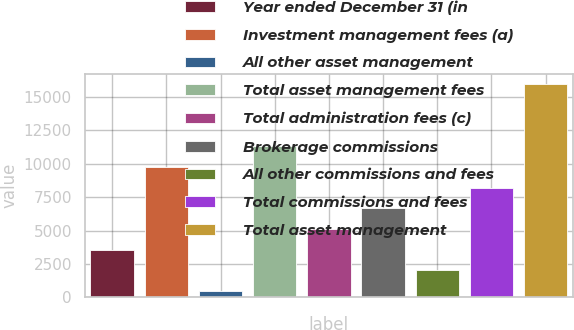Convert chart to OTSL. <chart><loc_0><loc_0><loc_500><loc_500><bar_chart><fcel>Year ended December 31 (in<fcel>Investment management fees (a)<fcel>All other asset management<fcel>Total asset management fees<fcel>Total administration fees (c)<fcel>Brokerage commissions<fcel>All other commissions and fees<fcel>Total commissions and fees<fcel>Total asset management<nl><fcel>3567.8<fcel>9749.4<fcel>477<fcel>11294.8<fcel>5113.2<fcel>6658.6<fcel>2022.4<fcel>8204<fcel>15931<nl></chart> 